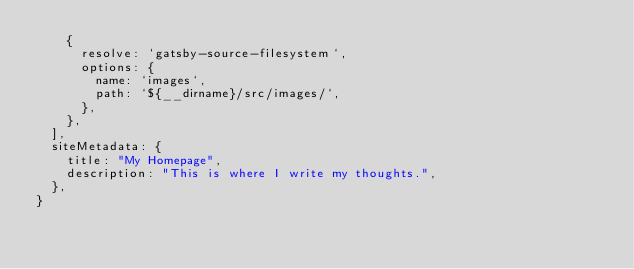<code> <loc_0><loc_0><loc_500><loc_500><_JavaScript_>    {
      resolve: `gatsby-source-filesystem`,
      options: {
        name: `images`,
        path: `${__dirname}/src/images/`,
      },
    },
  ],
  siteMetadata: {
    title: "My Homepage",
    description: "This is where I write my thoughts.",
  },
}
</code> 